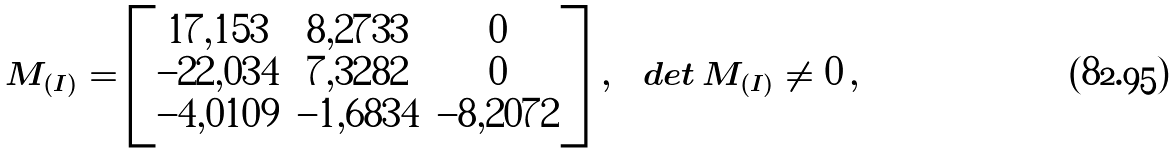<formula> <loc_0><loc_0><loc_500><loc_500>M _ { ( I ) } = \begin{bmatrix} 1 7 , 1 5 3 & 8 , 2 7 3 3 & 0 \\ - 2 2 , 0 3 4 & 7 , 3 2 8 2 & 0 \\ - 4 , 0 1 0 9 & - 1 , 6 8 3 4 & - 8 , 2 0 7 2 \end{bmatrix} \, , \quad d e t \, M _ { ( I ) } \not = 0 \, ,</formula> 